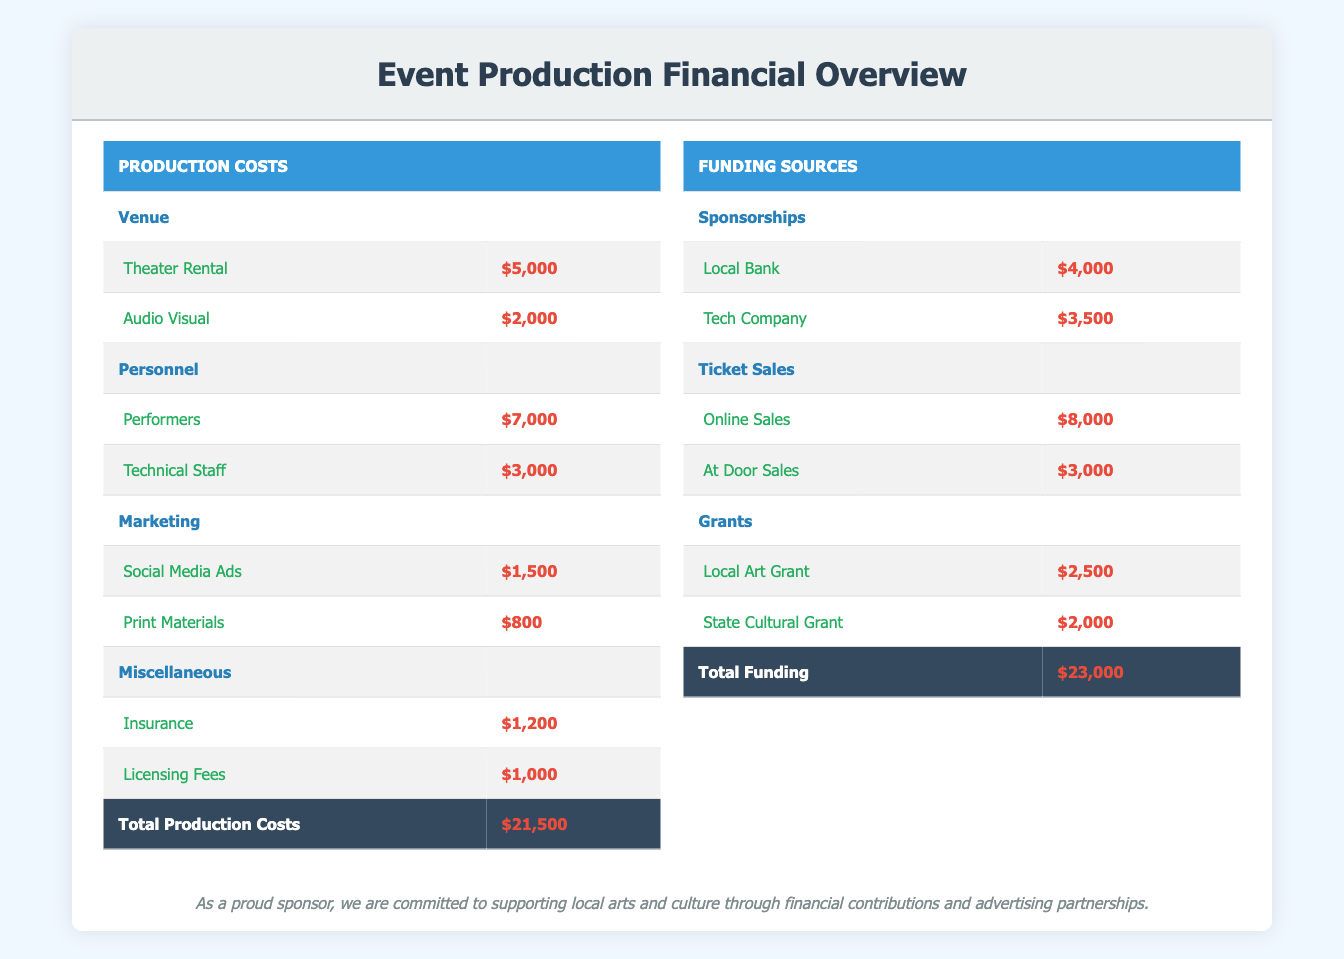What is the total amount spent on production costs? The total production costs are found in the last row of the Production Costs table, which shows $21,500.
Answer: 21,500 How much was spent on performers? The amount spent on performers is listed under Personnel in the Production Costs table, amounting to $7,000.
Answer: 7,000 Is the amount raised from ticket sales greater than the combined total of grants? The total from ticket sales is $11,000 ($8,000 from online sales + $3,000 from at door sales), while the total from grants is $4,500 ($2,500 from Local Art Grant + $2,000 from State Cultural Grant). Since $11,000 is greater than $4,500, the answer is yes.
Answer: Yes What is the total funding from sponsorships? The total from sponsorships can be calculated by adding $4,000 from Local Bank and $3,500 from Tech Company, which equals $7,500.
Answer: 7,500 What percentage of total production costs is allocated to marketing? The total marketing costs are $2,300 ($1,500 for Social Media Ads + $800 for Print Materials). To find the percentage, divide $2,300 by total production costs of $21,500 and multiply by 100, resulting in approximately 10.70%.
Answer: 10.70% How do the total funding sources compare to total production costs? Total funding amounts to $23,000. To compare, subtract total production costs of $21,500 from total funding of $23,000, which results in a difference of $1,500, indicating that funding exceeds costs.
Answer: Funding exceeds costs by 1,500 What is the total amount for miscellaneous expenses? The total for miscellaneous expenses is calculated by adding Insurance ($1,200) and Licensing Fees ($1,000), which equals $2,200.
Answer: 2,200 Does the amount raised from grants cover the total spending on venue costs? Total spending on venue costs is $7,000 ($5,000 for Theater Rental + $2,000 for Audio Visual), while total grants raised are $4,500. Since $4,500 is less than $7,000, the answer is no.
Answer: No 